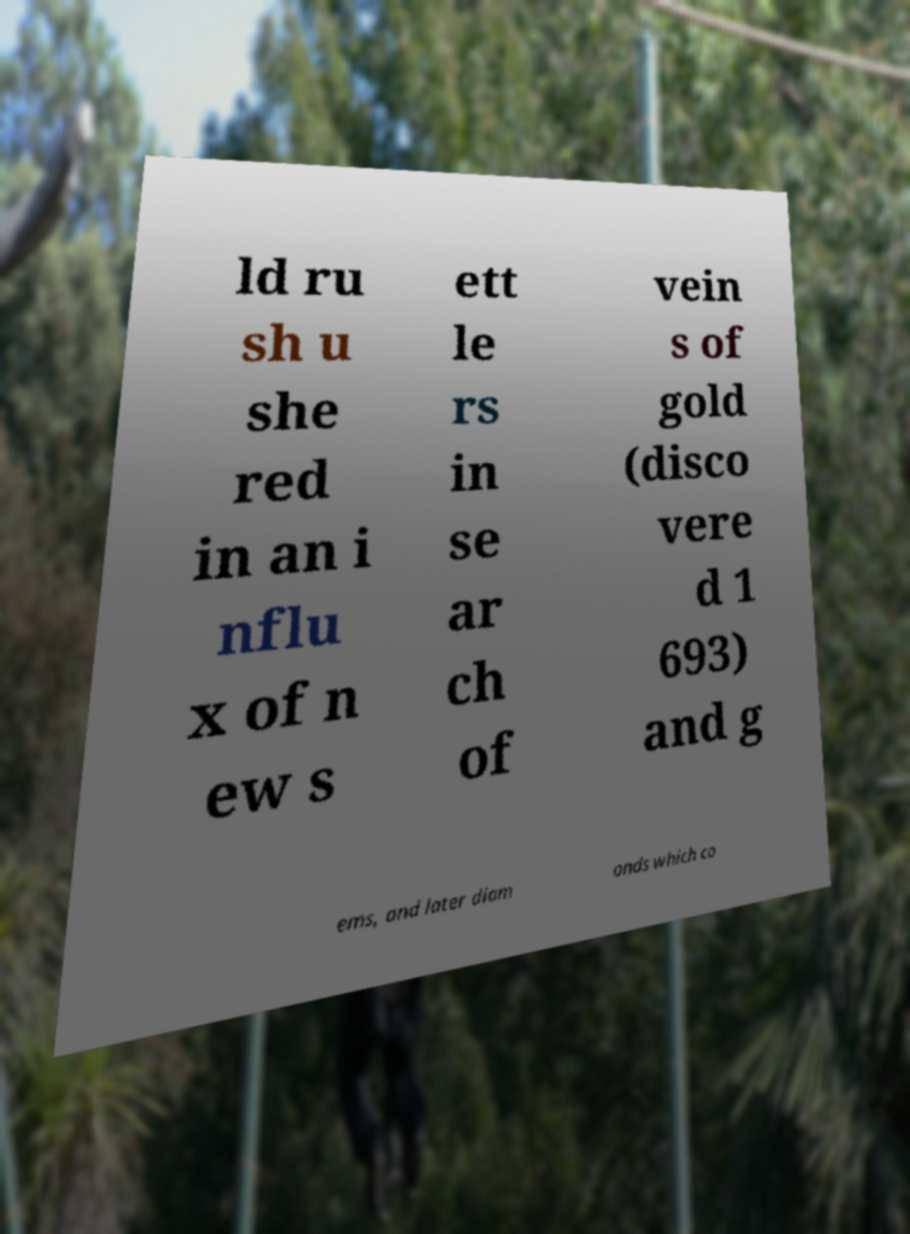For documentation purposes, I need the text within this image transcribed. Could you provide that? ld ru sh u she red in an i nflu x of n ew s ett le rs in se ar ch of vein s of gold (disco vere d 1 693) and g ems, and later diam onds which co 